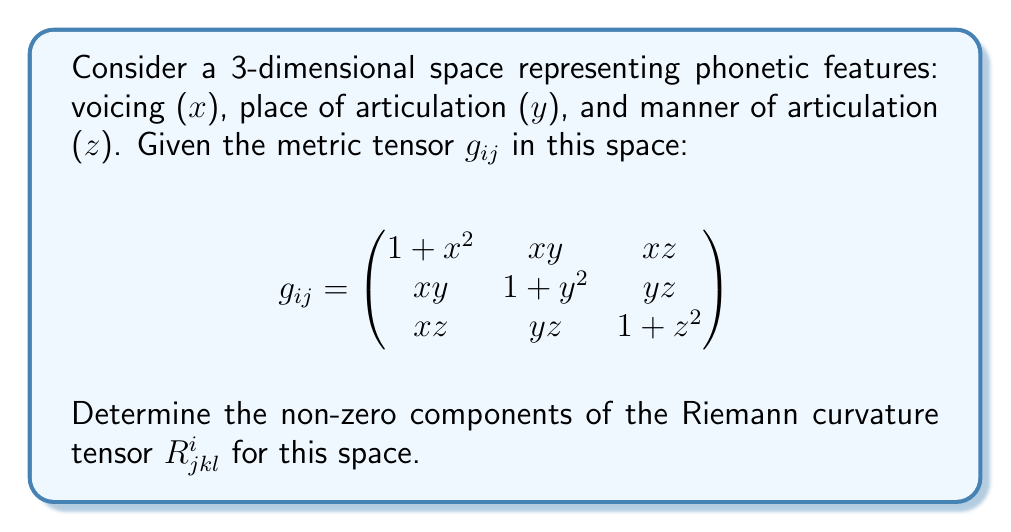Help me with this question. To determine the Riemann curvature tensor, we'll follow these steps:

1. Calculate the Christoffel symbols $\Gamma^i_{jk}$:
   $$\Gamma^i_{jk} = \frac{1}{2}g^{im}(\partial_j g_{km} + \partial_k g_{jm} - \partial_m g_{jk})$$

2. Calculate the Riemann curvature tensor:
   $$R^i_{jkl} = \partial_k \Gamma^i_{jl} - \partial_l \Gamma^i_{jk} + \Gamma^i_{km}\Gamma^m_{jl} - \Gamma^i_{lm}\Gamma^m_{jk}$$

3. For the given metric tensor:
   $$g^{ij} = \frac{1}{\det(g_{ij})} \text{adj}(g_{ij})$$
   where $\det(g_{ij}) = (1+x^2)(1+y^2)(1+z^2) - x^2y^2 - y^2z^2 - z^2x^2 - 2xyz$

4. Calculate the Christoffel symbols:
   $$\Gamma^1_{11} = \frac{x}{1+x^2}, \Gamma^1_{12} = \Gamma^1_{21} = \frac{y}{2(1+x^2)}, \Gamma^1_{13} = \Gamma^1_{31} = \frac{z}{2(1+x^2)}$$
   $$\Gamma^2_{22} = \frac{y}{1+y^2}, \Gamma^2_{12} = \Gamma^2_{21} = \frac{x}{2(1+y^2)}, \Gamma^2_{23} = \Gamma^2_{32} = \frac{z}{2(1+y^2)}$$
   $$\Gamma^3_{33} = \frac{z}{1+z^2}, \Gamma^3_{13} = \Gamma^3_{31} = \frac{x}{2(1+z^2)}, \Gamma^3_{23} = \Gamma^3_{32} = \frac{y}{2(1+z^2)}$$

5. Calculate the non-zero components of $R^i_{jkl}$:
   $$R^1_{212} = R^2_{121} = \frac{x^2y^2}{4(1+x^2)(1+y^2)} - \frac{1}{2(1+x^2)(1+y^2)}$$
   $$R^1_{313} = R^3_{131} = \frac{x^2z^2}{4(1+x^2)(1+z^2)} - \frac{1}{2(1+x^2)(1+z^2)}$$
   $$R^2_{323} = R^3_{232} = \frac{y^2z^2}{4(1+y^2)(1+z^2)} - \frac{1}{2(1+y^2)(1+z^2)}$$

The remaining non-zero components can be obtained by the symmetry properties of the Riemann tensor.
Answer: $R^1_{212} = R^2_{121} = \frac{x^2y^2}{4(1+x^2)(1+y^2)} - \frac{1}{2(1+x^2)(1+y^2)}$
$R^1_{313} = R^3_{131} = \frac{x^2z^2}{4(1+x^2)(1+z^2)} - \frac{1}{2(1+x^2)(1+z^2)}$
$R^2_{323} = R^3_{232} = \frac{y^2z^2}{4(1+y^2)(1+z^2)} - \frac{1}{2(1+y^2)(1+z^2)}$ 